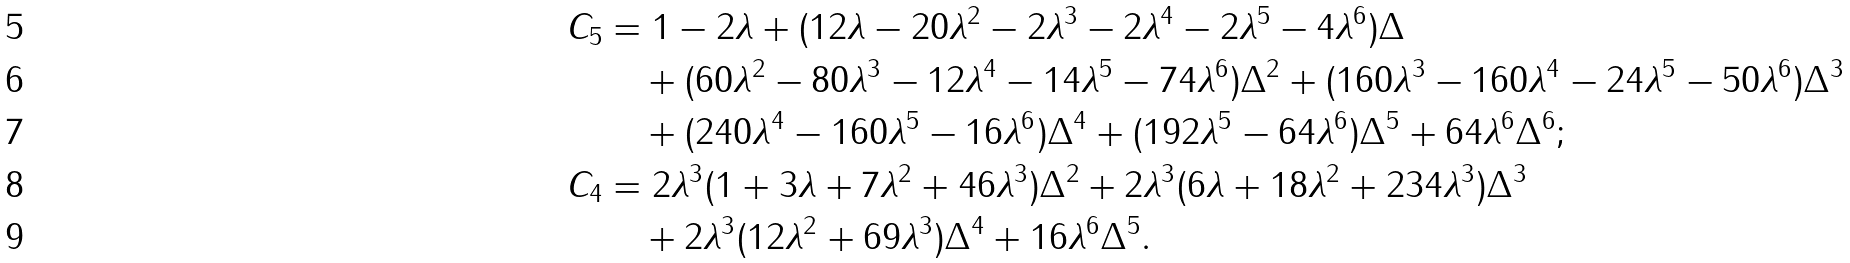Convert formula to latex. <formula><loc_0><loc_0><loc_500><loc_500>C _ { 5 } & = 1 - 2 \lambda + ( 1 2 \lambda - 2 0 \lambda ^ { 2 } - 2 \lambda ^ { 3 } - 2 \lambda ^ { 4 } - 2 \lambda ^ { 5 } - 4 \lambda ^ { 6 } ) \Delta \\ & \quad + ( 6 0 \lambda ^ { 2 } - 8 0 \lambda ^ { 3 } - 1 2 \lambda ^ { 4 } - 1 4 \lambda ^ { 5 } - 7 4 \lambda ^ { 6 } ) \Delta ^ { 2 } + ( 1 6 0 \lambda ^ { 3 } - 1 6 0 \lambda ^ { 4 } - 2 4 \lambda ^ { 5 } - 5 0 \lambda ^ { 6 } ) \Delta ^ { 3 } \\ & \quad + ( 2 4 0 \lambda ^ { 4 } - 1 6 0 \lambda ^ { 5 } - 1 6 \lambda ^ { 6 } ) \Delta ^ { 4 } + ( 1 9 2 \lambda ^ { 5 } - 6 4 \lambda ^ { 6 } ) \Delta ^ { 5 } + 6 4 \lambda ^ { 6 } \Delta ^ { 6 } ; \\ C _ { 4 } & = 2 \lambda ^ { 3 } ( 1 + 3 \lambda + 7 \lambda ^ { 2 } + 4 6 \lambda ^ { 3 } ) \Delta ^ { 2 } + 2 \lambda ^ { 3 } ( 6 \lambda + 1 8 \lambda ^ { 2 } + 2 3 4 \lambda ^ { 3 } ) \Delta ^ { 3 } \\ & \quad + 2 \lambda ^ { 3 } ( 1 2 \lambda ^ { 2 } + 6 9 \lambda ^ { 3 } ) \Delta ^ { 4 } + 1 6 \lambda ^ { 6 } \Delta ^ { 5 } .</formula> 